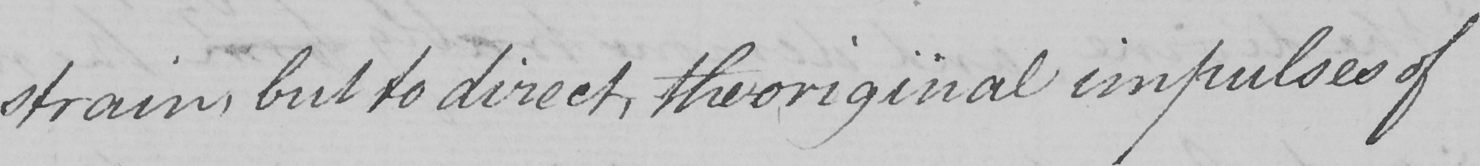Transcribe the text shown in this historical manuscript line. -strain , but to direct , the original impulses of 